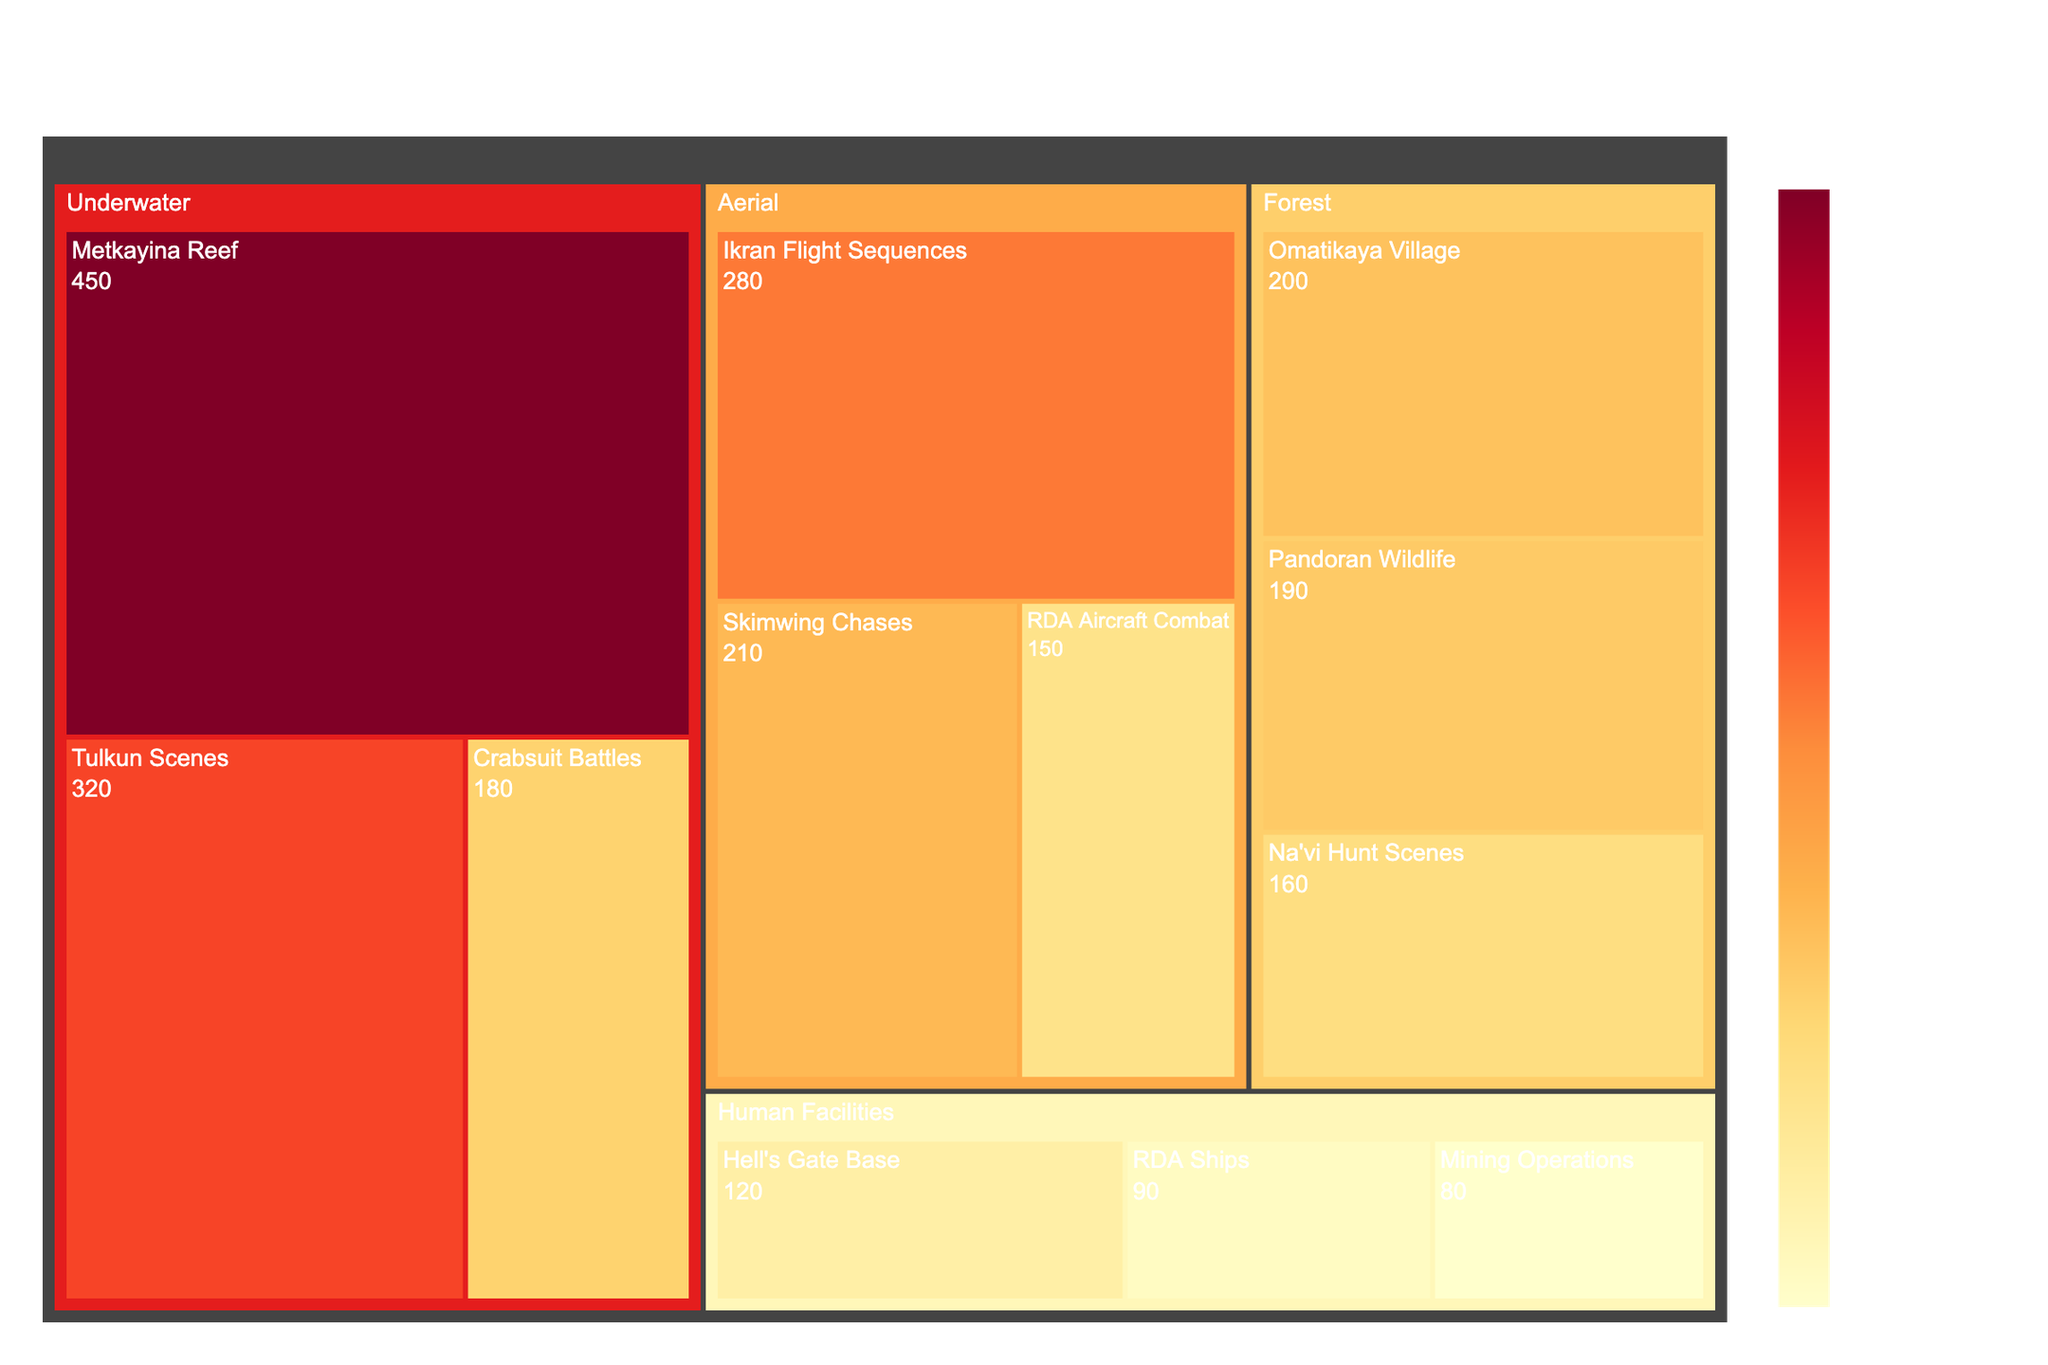What is the title of the plot? The title is typically positioned at the top center of the plot and is distinct in font size and style. In this case, it reads: "Distribution of Visual Effects Shots in Avatar: The Way of Water".
Answer: Distribution of Visual Effects Shots in Avatar: The Way of Water Which environment has the highest number of visual effects shots? By observing the size and color gradient of the sections, it's clear that "Underwater" occupies the largest area and spans the highest color intensity, indicating the highest total number of visual effects shots.
Answer: Underwater How many visual effects shots are in the Hell's Gate Base category? Hovering over the section or observing the labeled values within the treemap, we find that the "Hell's Gate Base" category contains 120 visual effects shots.
Answer: 120 What is the combined total of visual effects shots for the "Aerial" environment? Sum the values from all categories under the "Aerial" environment: Ikran Flight Sequences (280) + Skimwing Chases (210) + RDA Aircraft Combat (150). The total is 280 + 210 + 150 = 640.
Answer: 640 Which category in the "Forest" environment has the fewest visual effects shots? By comparing the sizes and the labeled values within the "Forest" environment, "Na'vi Hunt Scenes" with 160 shots is the smallest category.
Answer: Na'vi Hunt Scenes How does the number of visual effects shots in "Ikran Flight Sequences" compare to "Skimwing Chases"? The number of VFX shots in "Ikran Flight Sequences" is 280, whereas in "Skimwing Chases" it is 210. Since 280 is greater than 210, "Ikran Flight Sequences" has more VFX shots.
Answer: Ikran Flight Sequences has more What is the average number of visual effects shots in the "Human Facilities" environment? To find the average, sum the shots in all categories under "Human Facilities" and divide by the number of categories: (120 + 90 + 80) / 3 = 290 / 3 = approximately 96.67.
Answer: 96.67 Which environment has the most diverse set of categories? Diversity in this context means the number of distinct categories under each environment. Each environment in the treemap has three categories, so no environment is more diverse than the others.
Answer: All environments are equally diverse What is the difference in the number of visual effects shots between "Tulkun Scenes" and "Omatikaya Village"? "Tulkun Scenes" has 320 shots, and "Omatikaya Village" has 200 shots. The difference is 320 - 200 = 120.
Answer: 120 Which category overall has the single highest number of visual effects shots? By comparing the labeled values of all categories, "Metkayina Reef" in the "Underwater" environment with 450 shots is the highest.
Answer: Metkayina Reef 